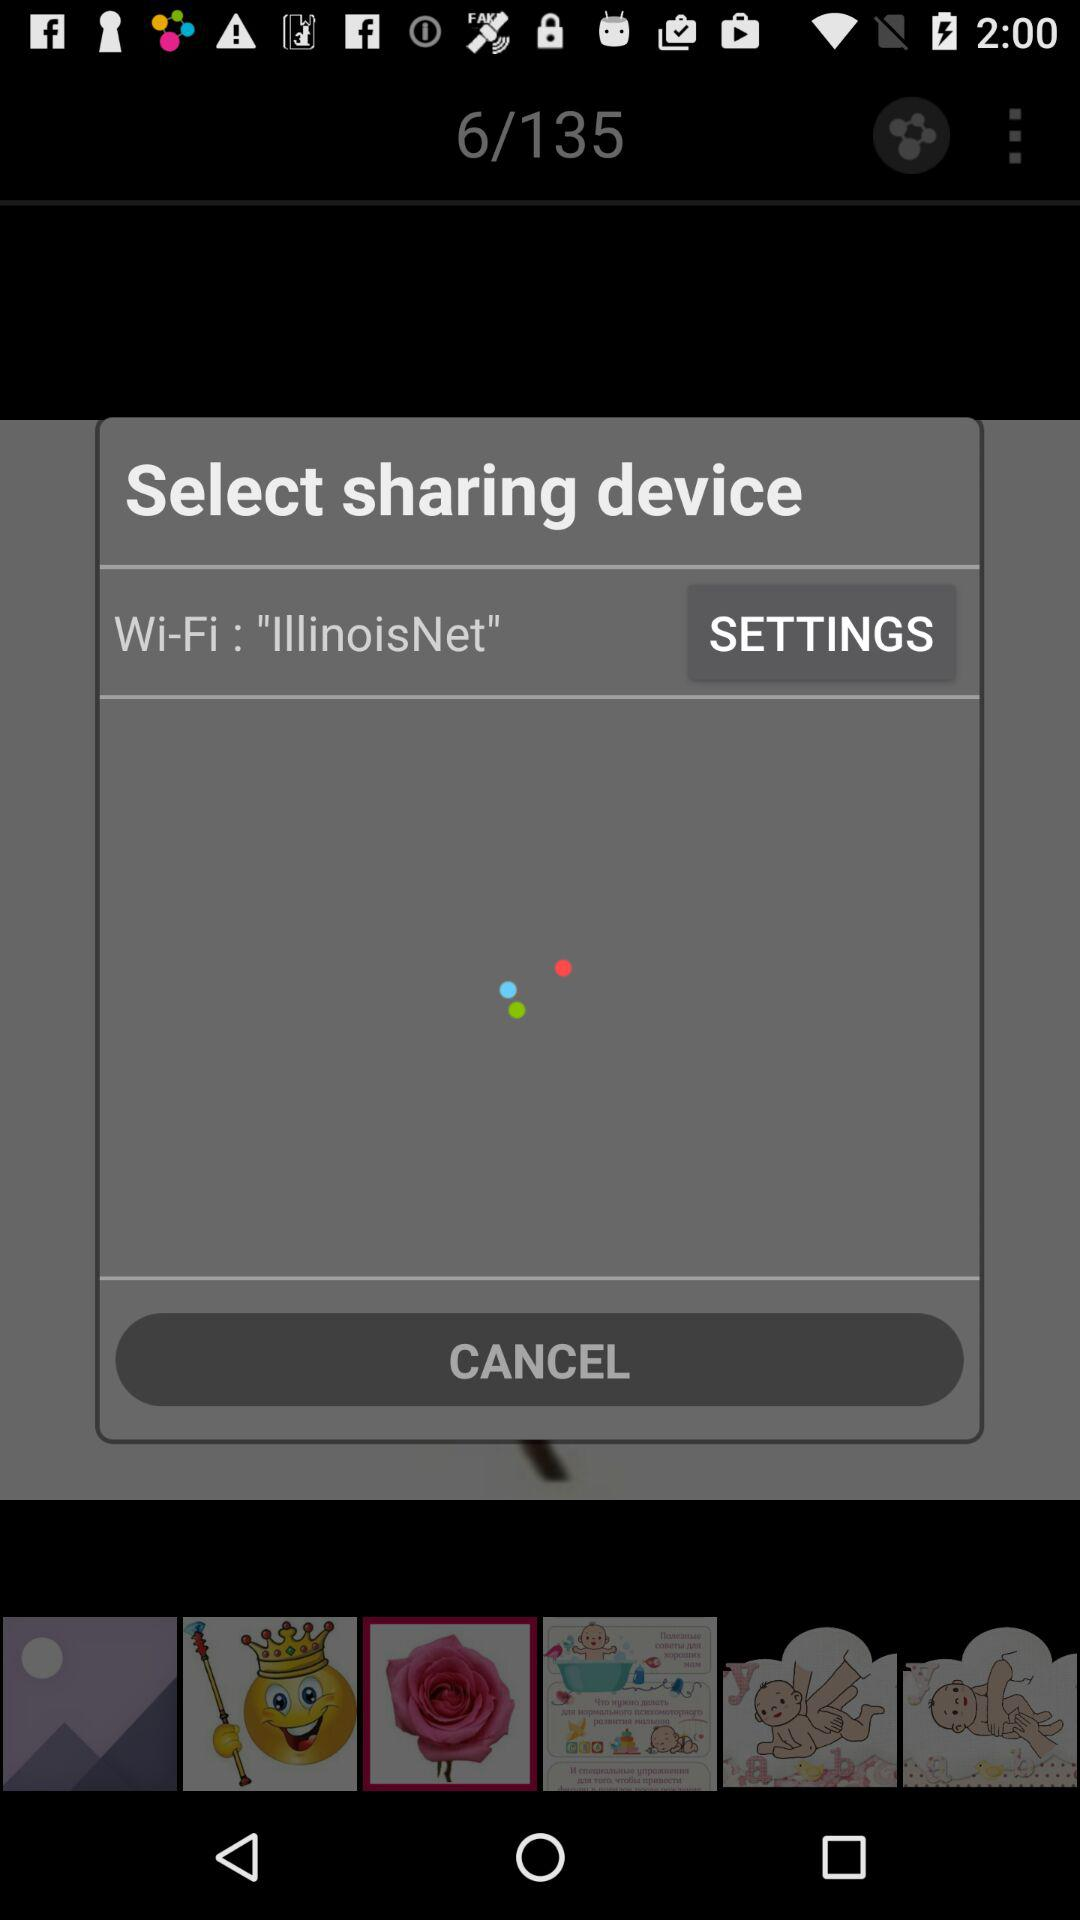What Wi-Fi network am I connected to? You are connected to the "IllinoisNet" Wi-Fi network. 